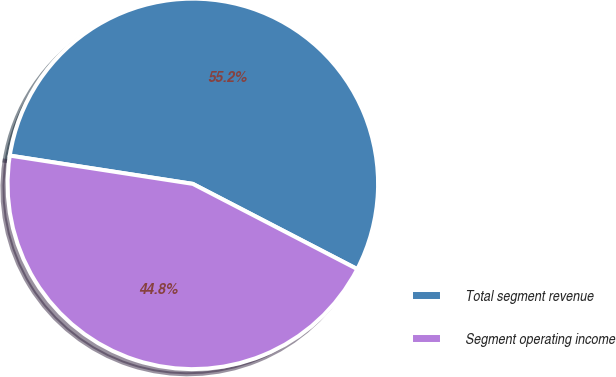Convert chart to OTSL. <chart><loc_0><loc_0><loc_500><loc_500><pie_chart><fcel>Total segment revenue<fcel>Segment operating income<nl><fcel>55.17%<fcel>44.83%<nl></chart> 